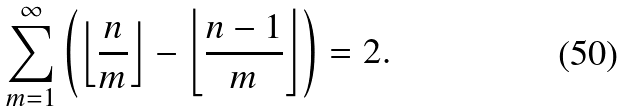Convert formula to latex. <formula><loc_0><loc_0><loc_500><loc_500>\sum _ { m = 1 } ^ { \infty } \left ( \left \lfloor { \frac { n } { m } } \right \rfloor - \left \lfloor { \frac { n - 1 } { m } } \right \rfloor \right ) = 2 .</formula> 